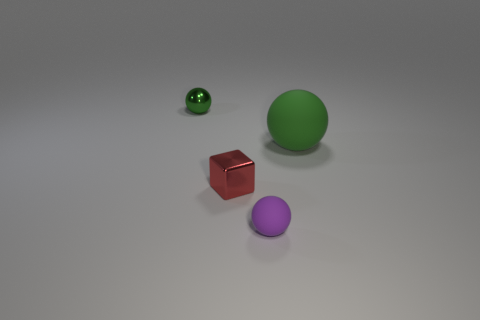Is the material of the purple object the same as the thing that is on the right side of the tiny purple thing?
Give a very brief answer. Yes. What number of big things are either rubber objects or metallic cubes?
Keep it short and to the point. 1. There is another large ball that is the same color as the metal sphere; what material is it?
Your answer should be very brief. Rubber. Are there fewer tiny purple blocks than red metal things?
Your answer should be compact. Yes. Do the purple matte sphere in front of the big green thing and the thing that is behind the big rubber ball have the same size?
Your response must be concise. Yes. What number of blue things are either shiny cubes or small rubber things?
Your answer should be compact. 0. The other ball that is the same color as the metallic ball is what size?
Your answer should be very brief. Large. Is the number of gray things greater than the number of small green objects?
Provide a short and direct response. No. Does the small rubber sphere have the same color as the shiny ball?
Offer a very short reply. No. What number of objects are small matte cylinders or tiny things behind the small red metallic cube?
Keep it short and to the point. 1. 